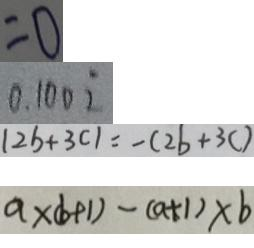Convert formula to latex. <formula><loc_0><loc_0><loc_500><loc_500>= 0 
 0 . 1 0 0 \dot { 2 } 
 \vert 2 b + 3 c \vert = - ( 2 b + 3 c ) 
 a \times ( b + 1 ) - ( a + 1 ) \times b</formula> 